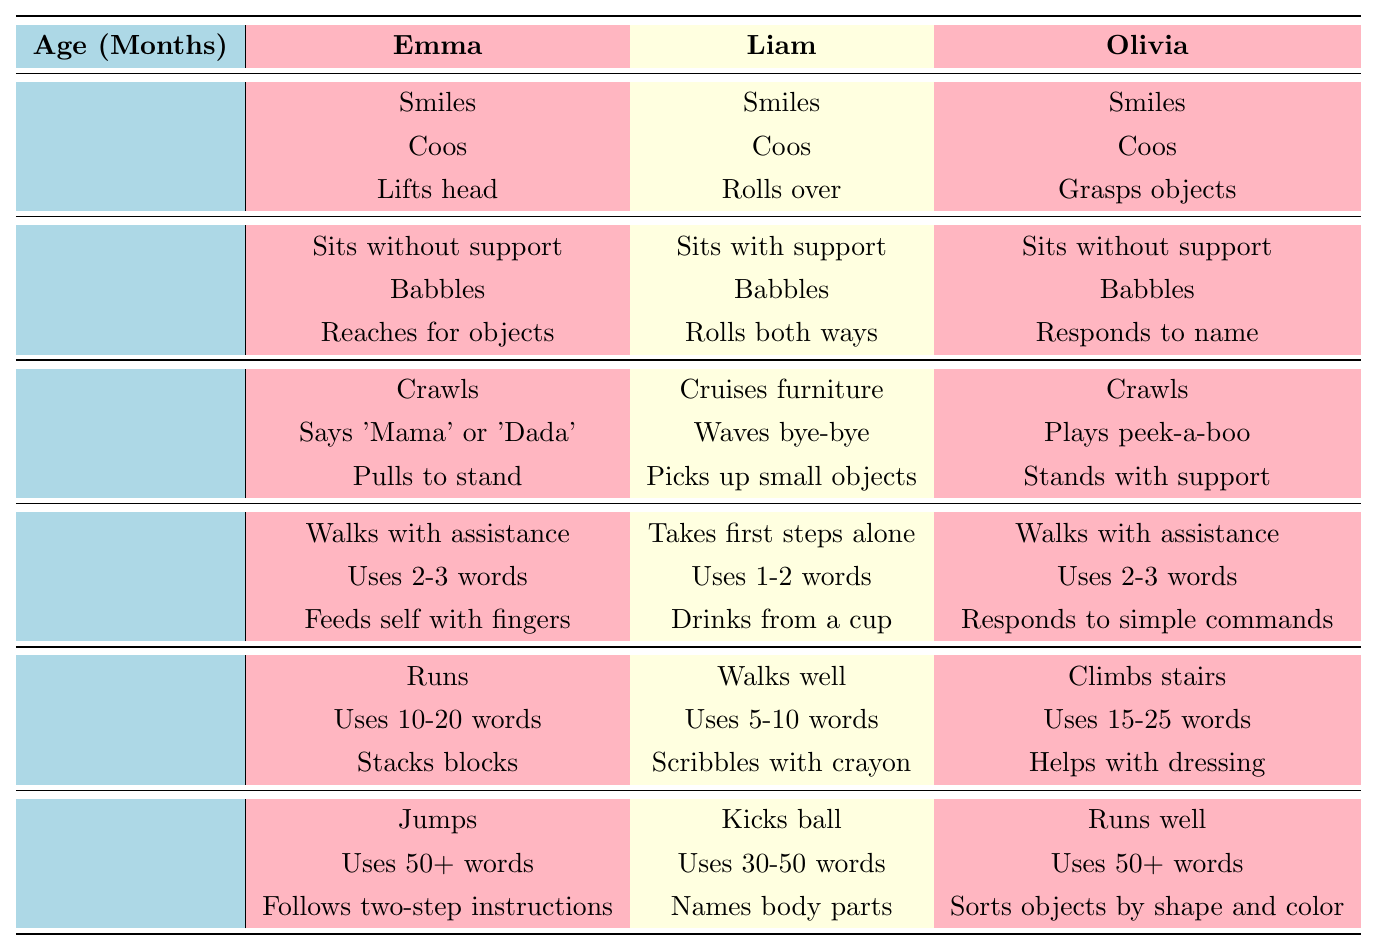What milestones did Olivia achieve at 12 months? At 12 months, Olivia achieved three milestones: "Walks with assistance," "Uses 2-3 words," and "Responds to simple commands." These are directly referenced in the table under the age of 12 months and for Olivia.
Answer: Walks with assistance, Uses 2-3 words, Responds to simple commands Which triplet can kick a ball at 24 months? In the table, under the age of 24 months, it states that Liam is the triplet who has achieved the milestone "Kicks ball."
Answer: Liam At what age did Emma start crawling? According to the table, Emma started crawling at 9 months, as indicated in the row corresponding to the age of 9 months.
Answer: 9 months Which triplet has the lowest number of words used at 18 months? The table shows that at 18 months, Liam uses 5-10 words, whereas Emma uses 10-20 words, and Olivia uses 15-25 words. Since Liam's range starts at 5, he has the lowest starting count.
Answer: Liam Did all triplets smile at 3 months? Yes, the table indicates that at 3 months, all three triplets (Emma, Liam, and Olivia) achieved the milestone of smiling as they each have "Smiles" listed under their names.
Answer: Yes How many milestones did Emma achieve by 24 months? By looking at the table, Emma has achieved three milestones at each age: 3, 6, 9, 12, 18, and 24 months. This totals to 3 milestones for each of the 6 ages, resulting in a total of 18 milestones. The calculation is 3 milestones x 6 age groups = 18.
Answer: 18 What is the difference in the number of words used by Liam and Olivia at 24 months? At 24 months, Liam uses 30-50 words and Olivia uses 50+ words. The range for Liam starts at 30 and Olivia at 50, thus the difference in their minimum word count is 50 - 30 = 20 words.
Answer: 20 words Which triplet made their first steps alone at 12 months? The table specifies that Liam takes his first steps alone at 12 months, as indicated in the corresponding section for that age.
Answer: Liam At what age did both Emma and Olivia start responding to their names? Both Emma and Olivia started responding to their names at 6 months, as stated in the milestones section under their names for that age.
Answer: 6 months How many milestones did each triplet achieve at 6 months? According to the table, each triplet achieved 3 milestones at 6 months: Emma achieved "Sits without support," "Babbles," and "Reaches for objects"; Liam achieved "Sits with support," "Babbles," and "Rolls both ways"; Olivia achieved "Sits without support," "Babbles," and "Responds to name." So each triplet has achieved 3 milestones at that age.
Answer: 3 milestones 